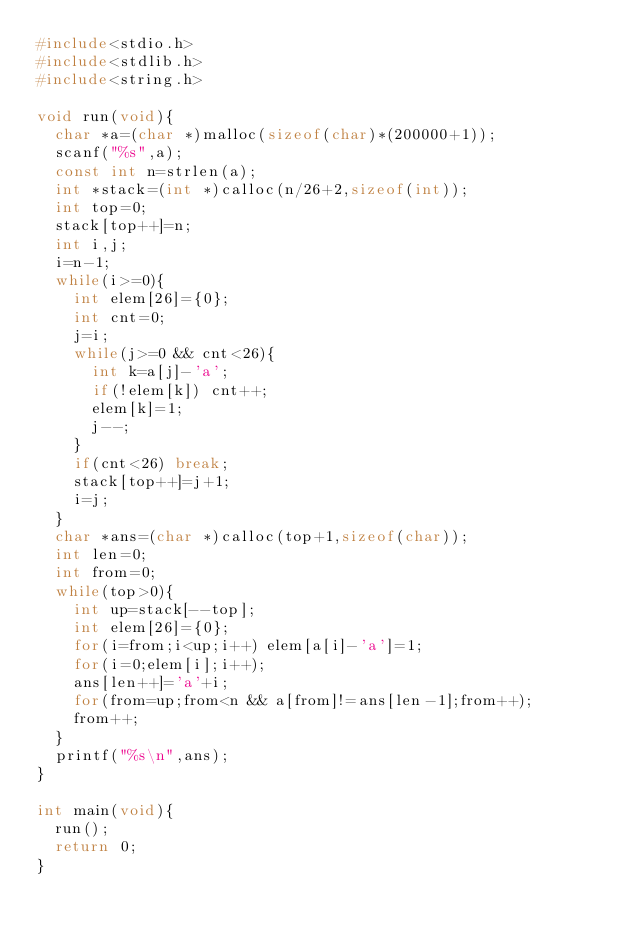Convert code to text. <code><loc_0><loc_0><loc_500><loc_500><_C_>#include<stdio.h>
#include<stdlib.h>
#include<string.h>

void run(void){
  char *a=(char *)malloc(sizeof(char)*(200000+1));
  scanf("%s",a);
  const int n=strlen(a);
  int *stack=(int *)calloc(n/26+2,sizeof(int));
  int top=0;
  stack[top++]=n;
  int i,j;
  i=n-1;
  while(i>=0){
    int elem[26]={0};
    int cnt=0;
    j=i;
    while(j>=0 && cnt<26){
      int k=a[j]-'a';
      if(!elem[k]) cnt++;
      elem[k]=1;
      j--;
    }
    if(cnt<26) break;
    stack[top++]=j+1;
    i=j;
  }
  char *ans=(char *)calloc(top+1,sizeof(char));
  int len=0;
  int from=0;
  while(top>0){
    int up=stack[--top];
    int elem[26]={0};
    for(i=from;i<up;i++) elem[a[i]-'a']=1;
    for(i=0;elem[i];i++);
    ans[len++]='a'+i;
    for(from=up;from<n && a[from]!=ans[len-1];from++);
    from++;
  }
  printf("%s\n",ans);
}

int main(void){
  run();
  return 0;
}
</code> 